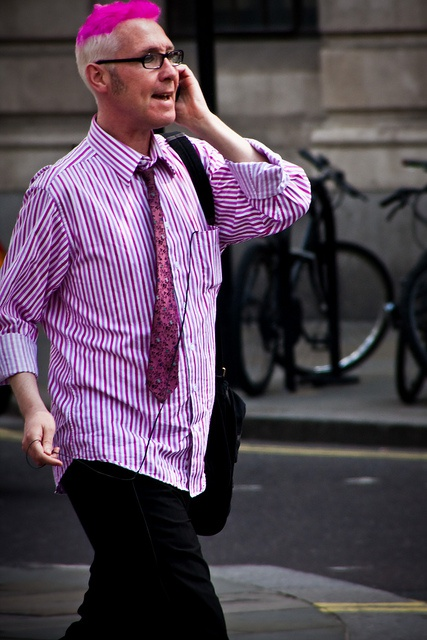Describe the objects in this image and their specific colors. I can see people in black, lavender, and purple tones, bicycle in black and gray tones, handbag in black, gray, navy, and purple tones, bicycle in black and gray tones, and tie in black and purple tones in this image. 